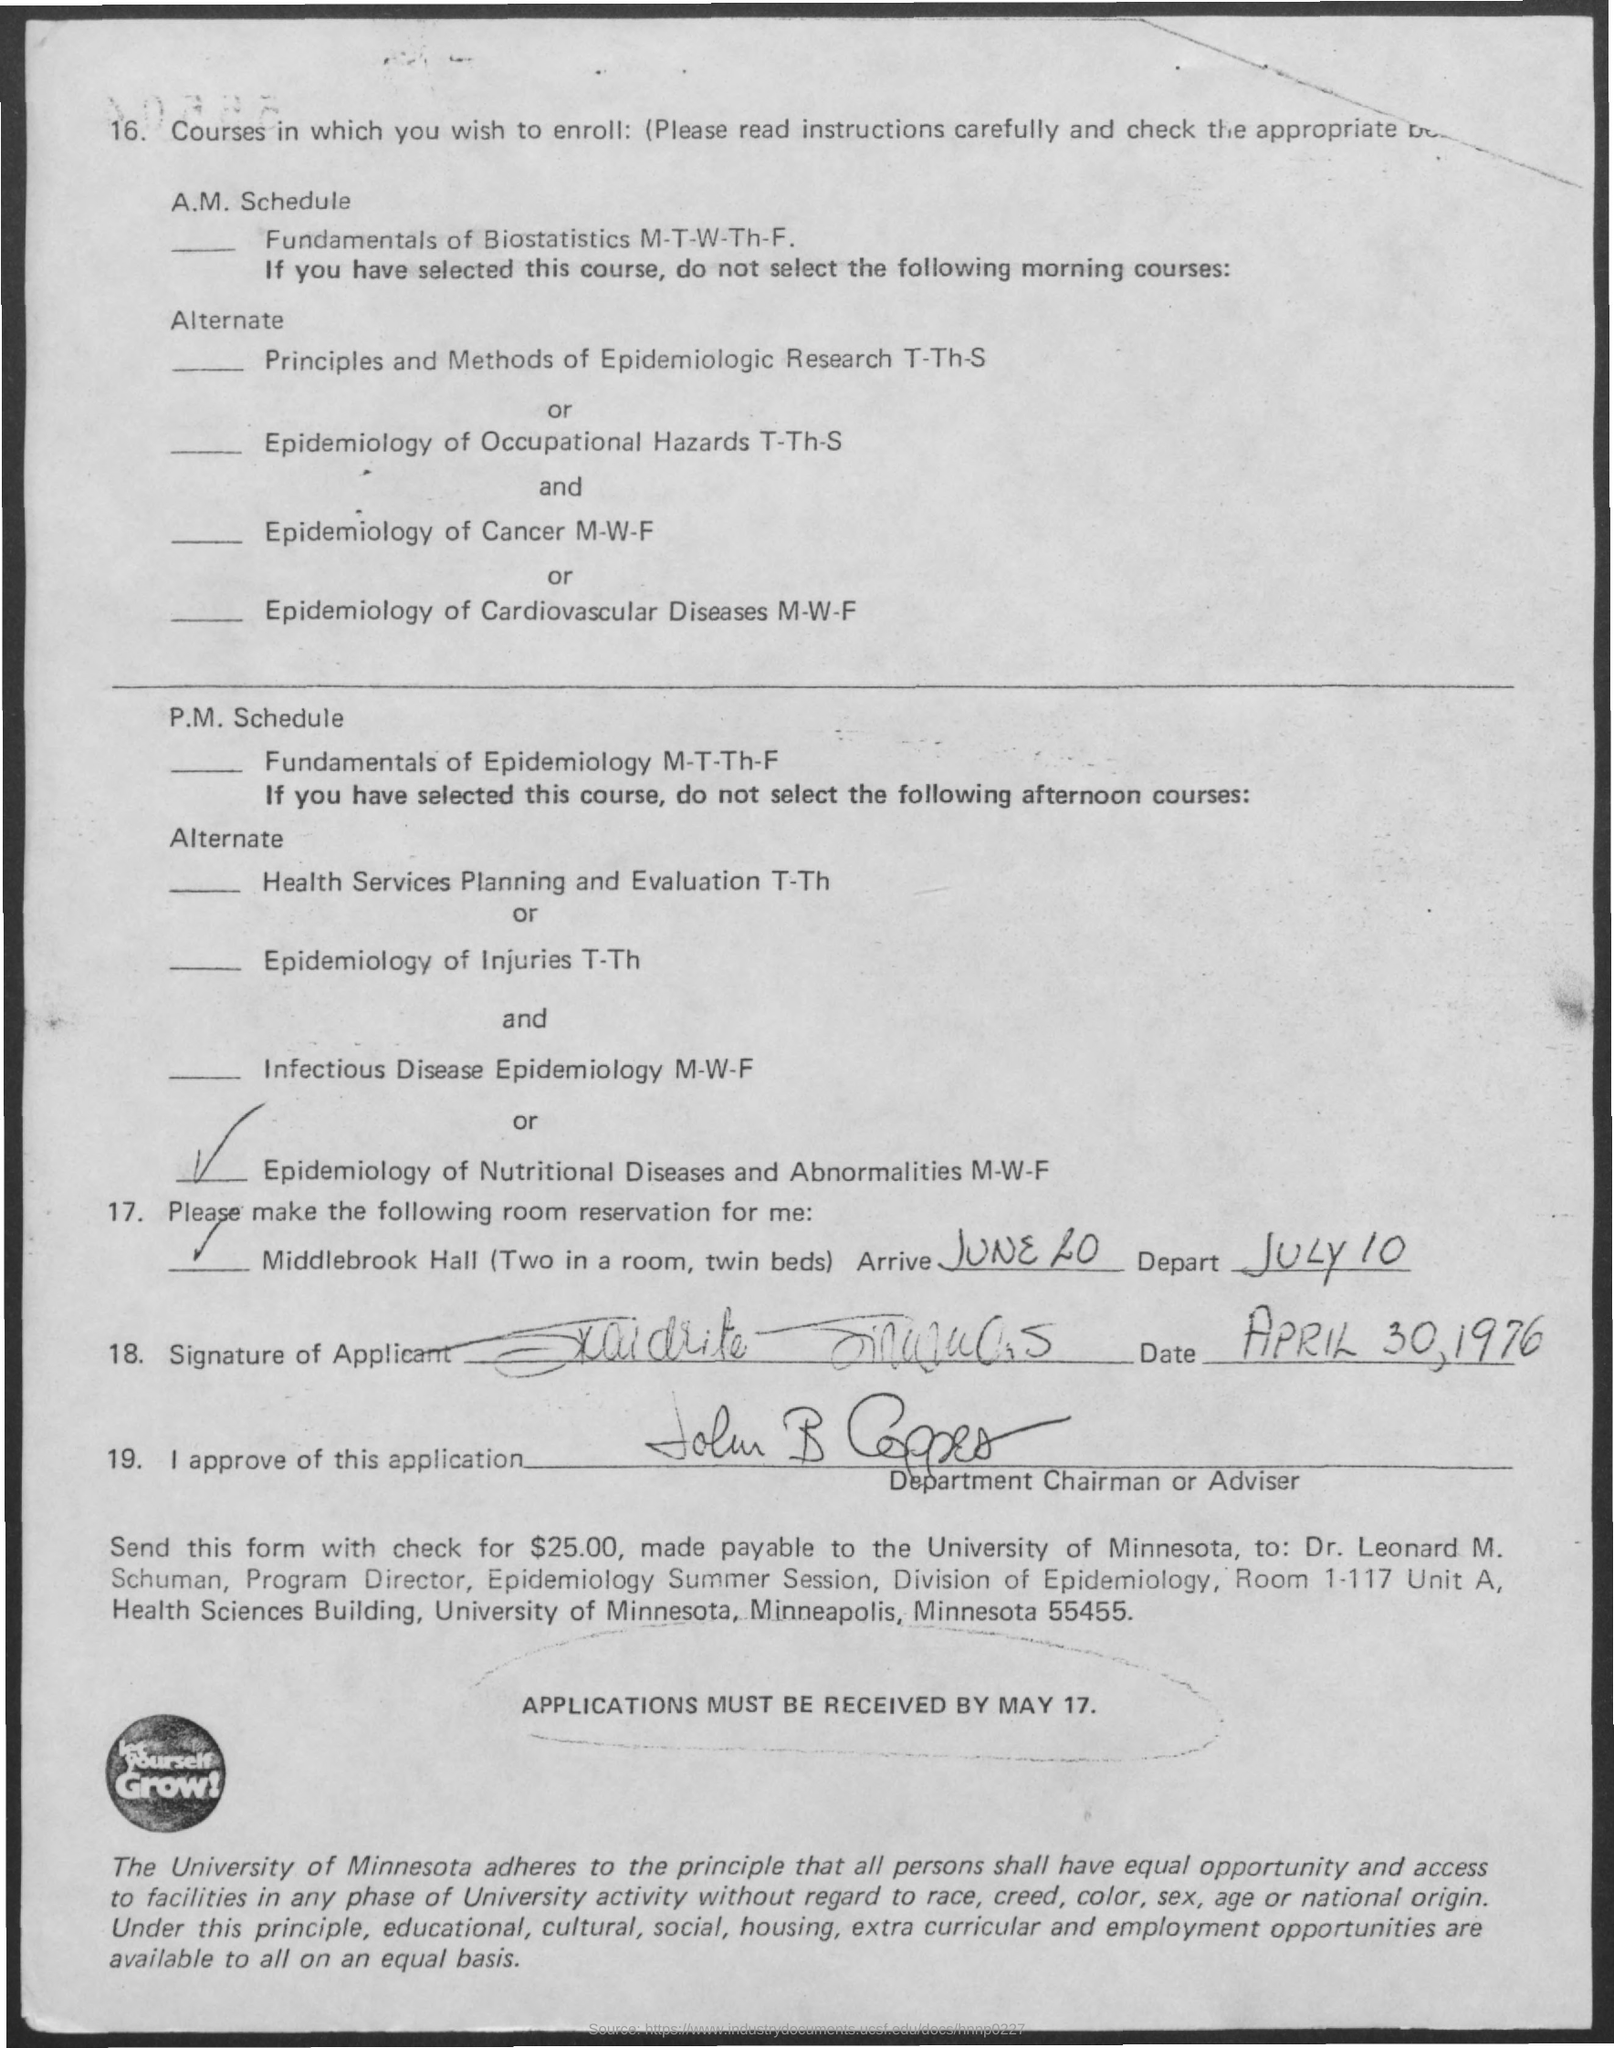What's last date to receive the form by university?
Make the answer very short. May 17. 